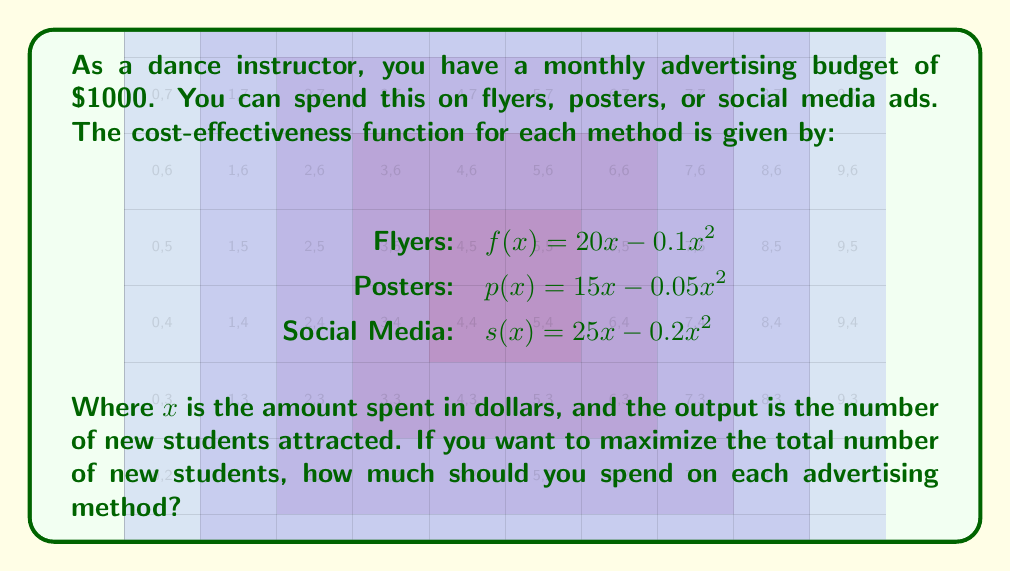Solve this math problem. 1) To maximize the total number of new students, we need to find the maximum value for each function within the budget constraint.

2) For each function, we can find the maximum by differentiating and setting to zero:

   Flyers: $f'(x) = 20 - 0.2x = 0$
           $20 = 0.2x$
           $x = 100$

   Posters: $p'(x) = 15 - 0.1x = 0$
            $15 = 0.1x$
            $x = 150$

   Social Media: $s'(x) = 25 - 0.4x = 0$
                 $25 = 0.4x$
                 $x = 62.5$

3) The optimal spending for each method would be:
   Flyers: $100
   Posters: $150
   Social Media: $62.5

4) The total spending is $100 + $150 + $62.5 = $312.5, which is within our $1000 budget.

5) To confirm this is the global maximum within our budget constraint, we can calculate the number of new students for each method:

   Flyers: $f(100) = 20(100) - 0.1(100)^2 = 1000$
   Posters: $p(150) = 15(150) - 0.05(150)^2 = 1125$
   Social Media: $s(62.5) = 25(62.5) - 0.2(62.5)^2 = 781.25$

6) The total number of new students is 1000 + 1125 + 781.25 = 2906.25

7) Any other combination of spending that totals $312.5 or less will result in fewer new students.
Answer: Flyers: $100, Posters: $150, Social Media: $62.5 